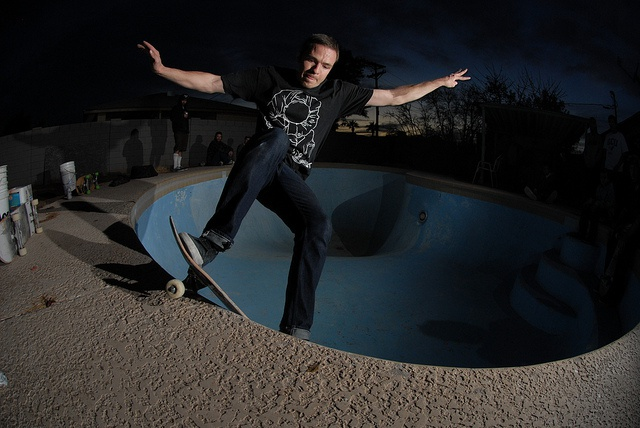Describe the objects in this image and their specific colors. I can see people in black, gray, and darkgray tones, skateboard in black, gray, and blue tones, people in black and gray tones, people in black tones, and people in black tones in this image. 